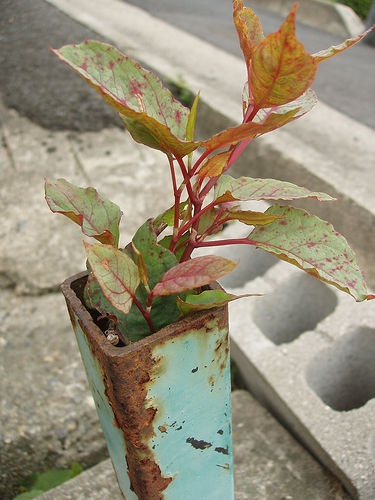Describe the objects in this image and their specific colors. I can see a potted plant in gray, darkgray, tan, and olive tones in this image. 